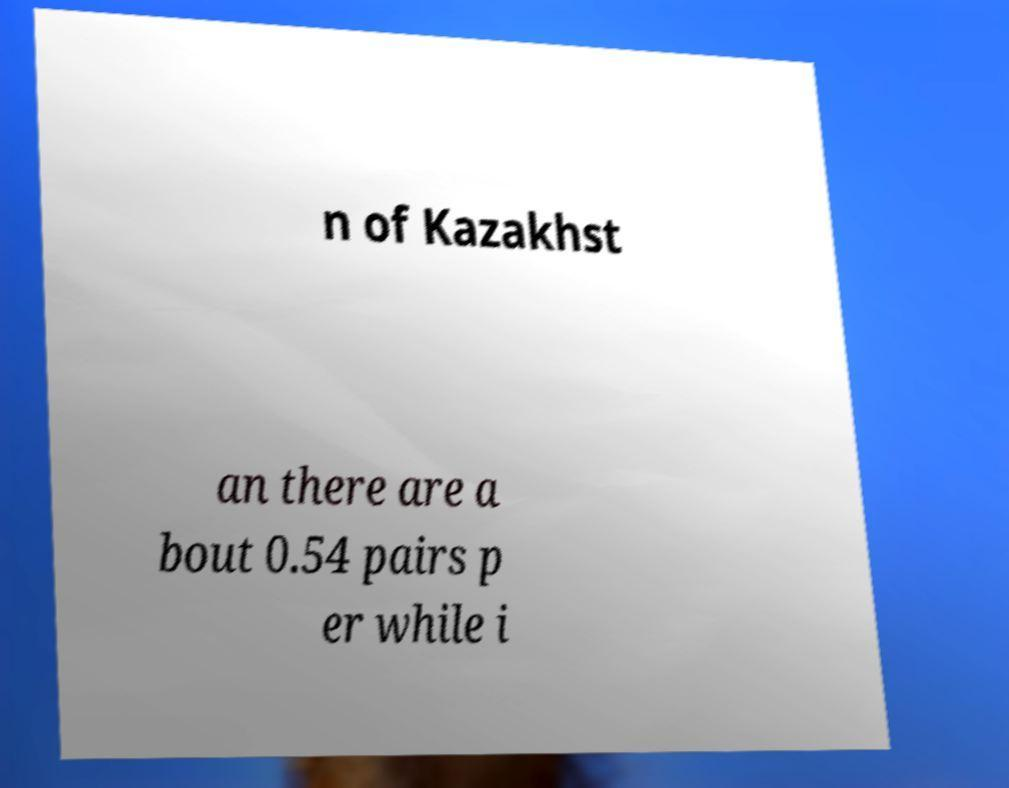Please identify and transcribe the text found in this image. n of Kazakhst an there are a bout 0.54 pairs p er while i 